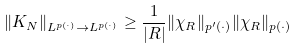<formula> <loc_0><loc_0><loc_500><loc_500>\| K _ { N } \| _ { L ^ { p ( \cdot ) } \to L ^ { p ( \cdot ) } } \geq \frac { 1 } { | R | } \| \chi _ { R } \| _ { p ^ { \prime } ( \cdot ) } \| \chi _ { R } \| _ { p ( \cdot ) }</formula> 